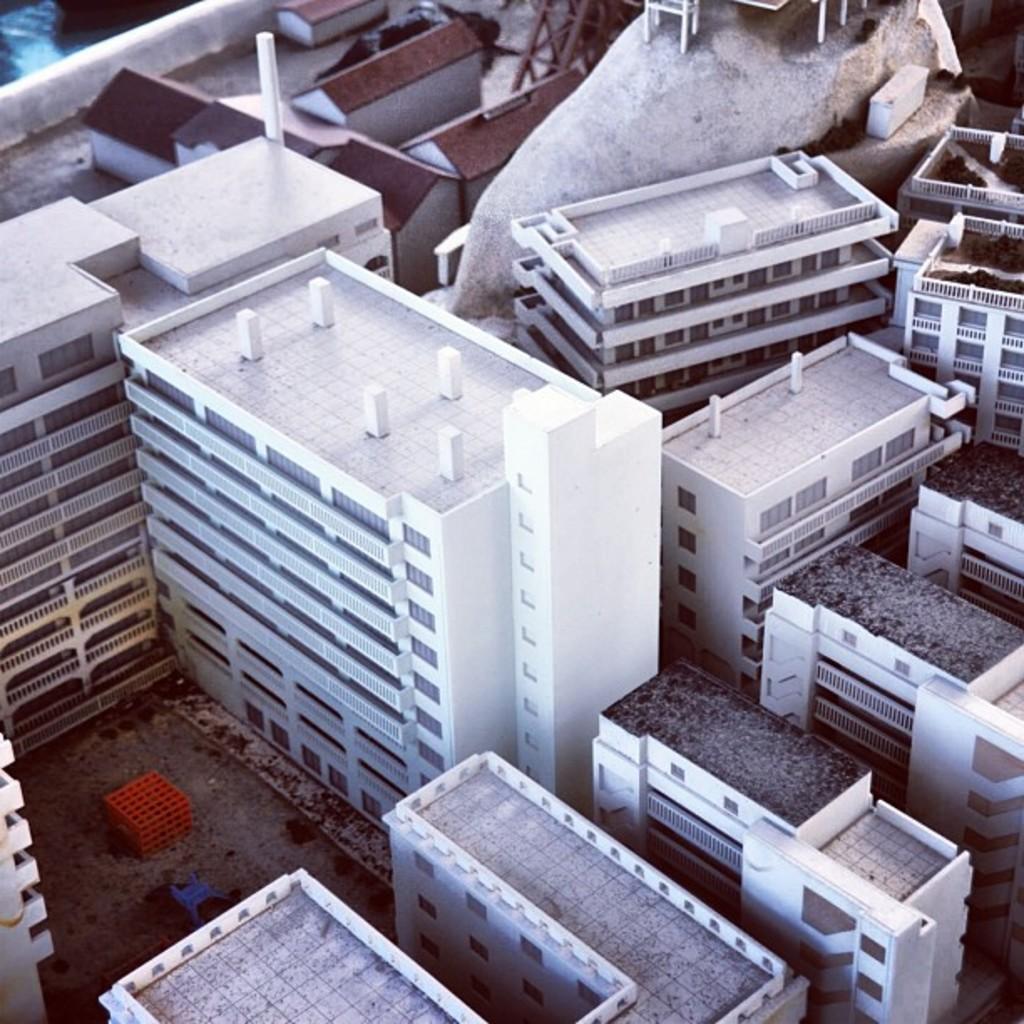Could you give a brief overview of what you see in this image? In this image I can see number of buildings which are white , brown and black in color. I can see the ground and on the ground I can see few blue and red colored objects. 